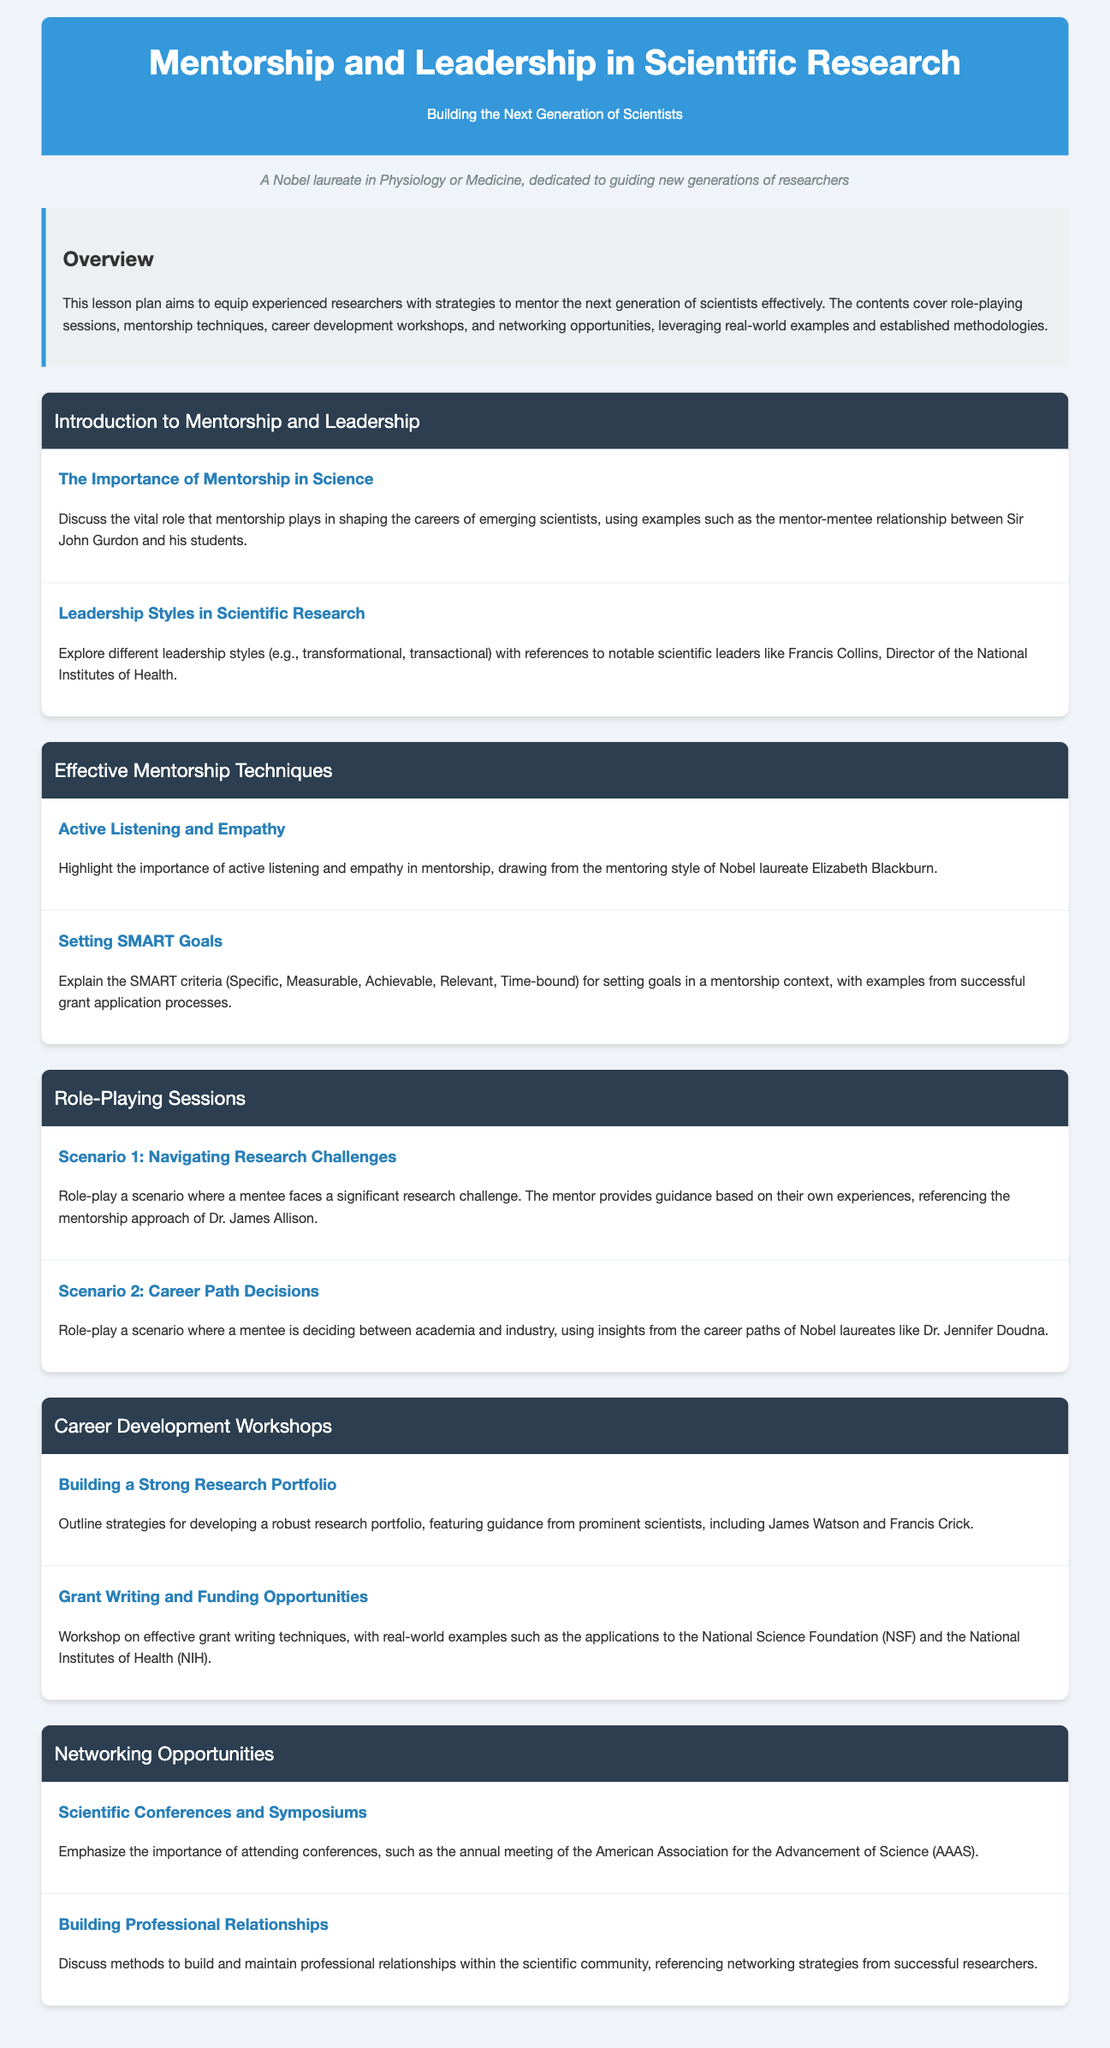What is the title of the lesson plan? The title is stated prominently at the top of the document.
Answer: Mentorship and Leadership in Scientific Research What is the primary focus of the lesson plan? The overview section outlines the main aim of the lesson plan.
Answer: Equipping experienced researchers with strategies to mentor Who is referenced as a notable scientific leader? The document mentions Francis Collins in relation to leadership styles.
Answer: Francis Collins What are the SMART goals? SMART goals are defined in a subsection explaining mentorship techniques.
Answer: Specific, Measurable, Achievable, Relevant, Time-bound Which Nobel laureate is highlighted for her mentoring style? The subsection specifies Elizabeth Blackburn for her approaches in mentorship.
Answer: Elizabeth Blackburn What is the first scenario in the role-playing sessions? The title of the first scenario is found in the Role-Playing Sessions section.
Answer: Navigating Research Challenges What is emphasized in the Networking Opportunities section? The subsection points out the significance of attending scientific events.
Answer: Importance of attending conferences Which two prominent scientists are mentioned for building a research portfolio? The workshop subsection names James Watson and Francis Crick.
Answer: James Watson and Francis Crick What is the focus of the workshop on grant writing? The document states that the workshop addresses effective grant writing techniques.
Answer: Effective grant writing techniques 